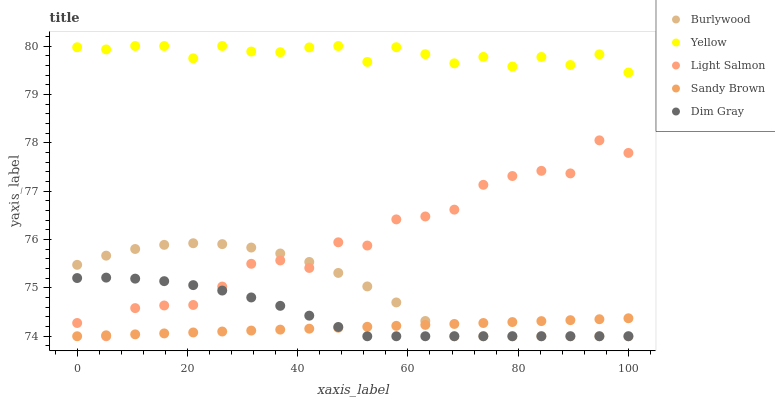Does Sandy Brown have the minimum area under the curve?
Answer yes or no. Yes. Does Yellow have the maximum area under the curve?
Answer yes or no. Yes. Does Light Salmon have the minimum area under the curve?
Answer yes or no. No. Does Light Salmon have the maximum area under the curve?
Answer yes or no. No. Is Sandy Brown the smoothest?
Answer yes or no. Yes. Is Light Salmon the roughest?
Answer yes or no. Yes. Is Dim Gray the smoothest?
Answer yes or no. No. Is Dim Gray the roughest?
Answer yes or no. No. Does Burlywood have the lowest value?
Answer yes or no. Yes. Does Yellow have the lowest value?
Answer yes or no. No. Does Yellow have the highest value?
Answer yes or no. Yes. Does Light Salmon have the highest value?
Answer yes or no. No. Is Sandy Brown less than Yellow?
Answer yes or no. Yes. Is Yellow greater than Burlywood?
Answer yes or no. Yes. Does Light Salmon intersect Burlywood?
Answer yes or no. Yes. Is Light Salmon less than Burlywood?
Answer yes or no. No. Is Light Salmon greater than Burlywood?
Answer yes or no. No. Does Sandy Brown intersect Yellow?
Answer yes or no. No. 